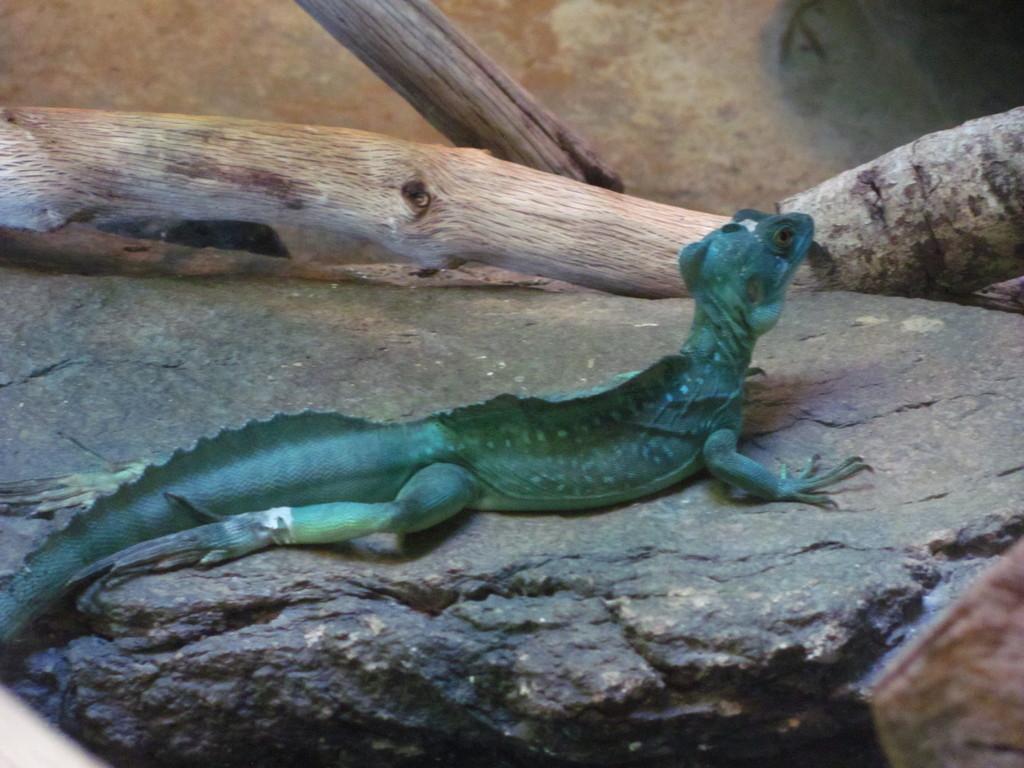Please provide a concise description of this image. In this picture we can see a reptile on the rock, in the background there is some wood. 